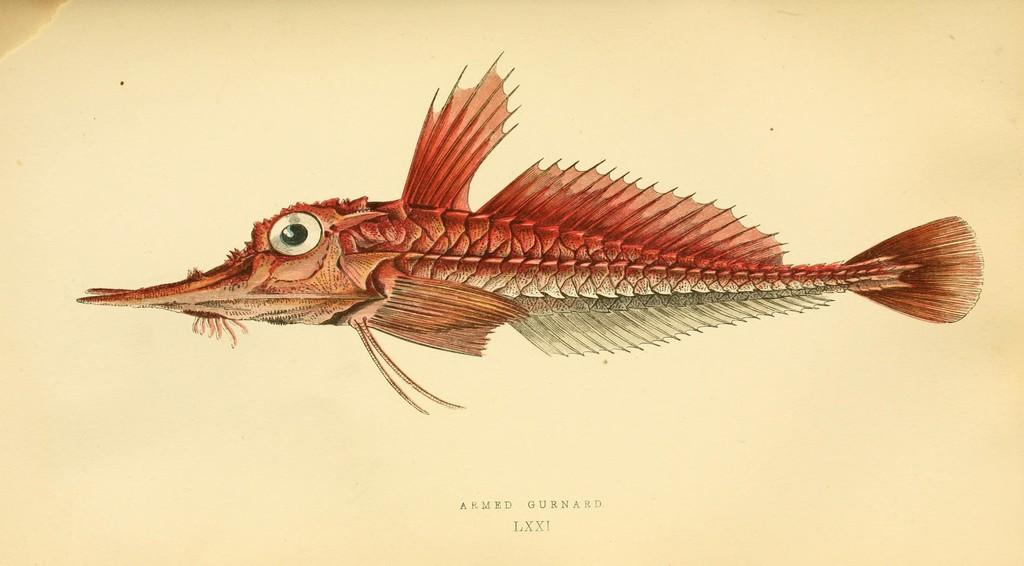What is the main subject of the image on the page? There is a fish depicted on the page. What else can be found on the page besides the image of the fish? There is text on the page. What type of furniture is shown in the image? There is no furniture shown in the image; it features a fish and text. Can you tell me how many people are asking for help in the image? There is no indication of people asking for help in the image, as it only contains a fish and text. 